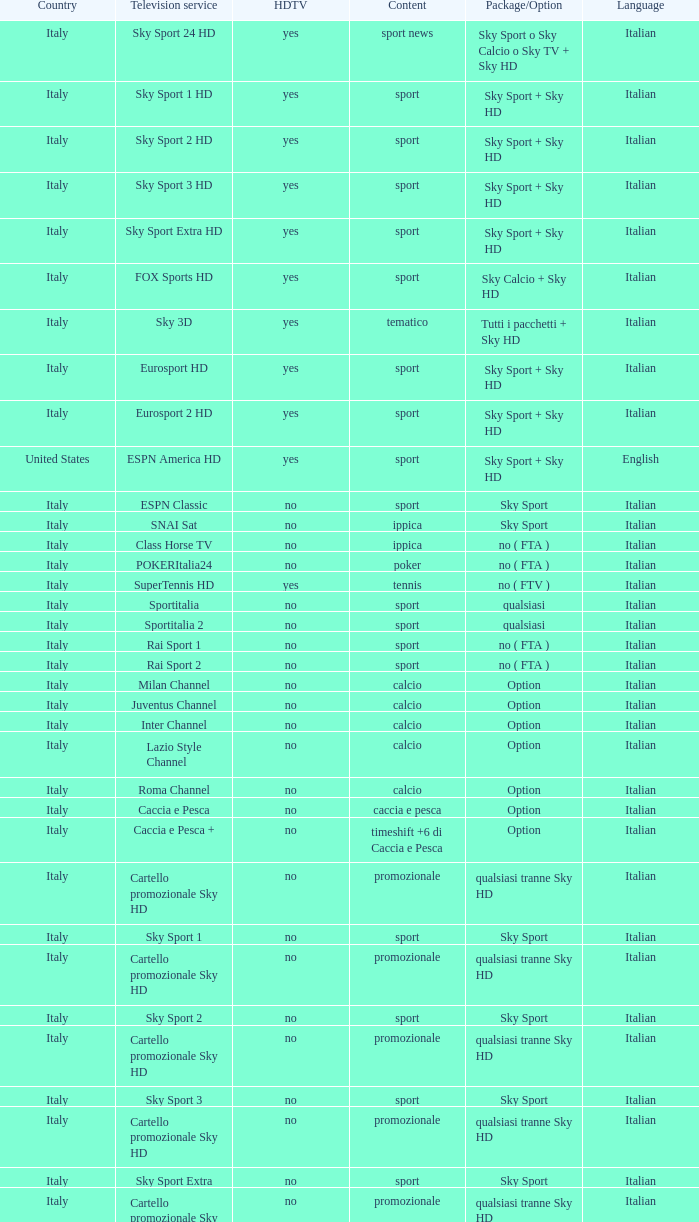What is Country, when Television Service is Eurosport 2? Italy. 